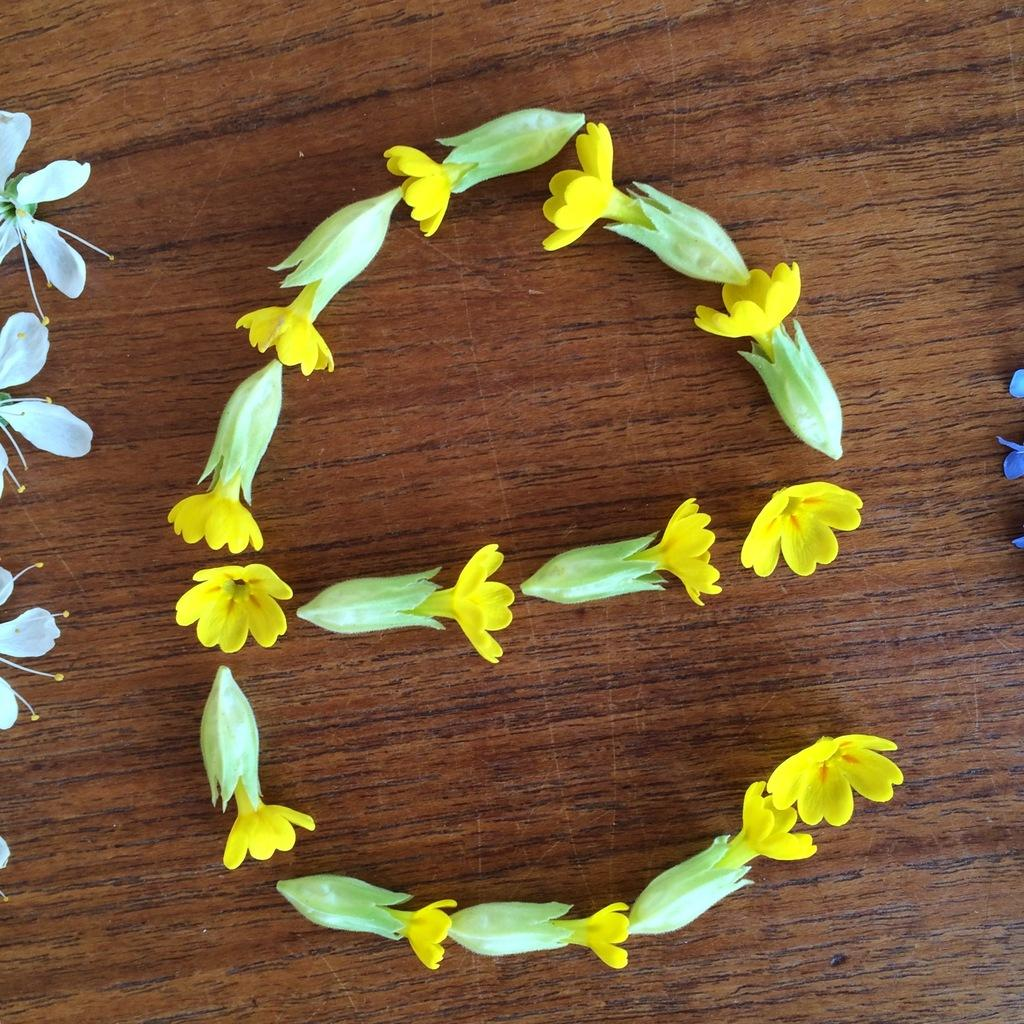What type of plants are present in the image? There are flowers in the image. What is the flowers resting on in the image? The flowers are on a wooden surface. Can you see the ocean in the background of the image? There is no ocean present in the image; it only features flowers on a wooden surface. 